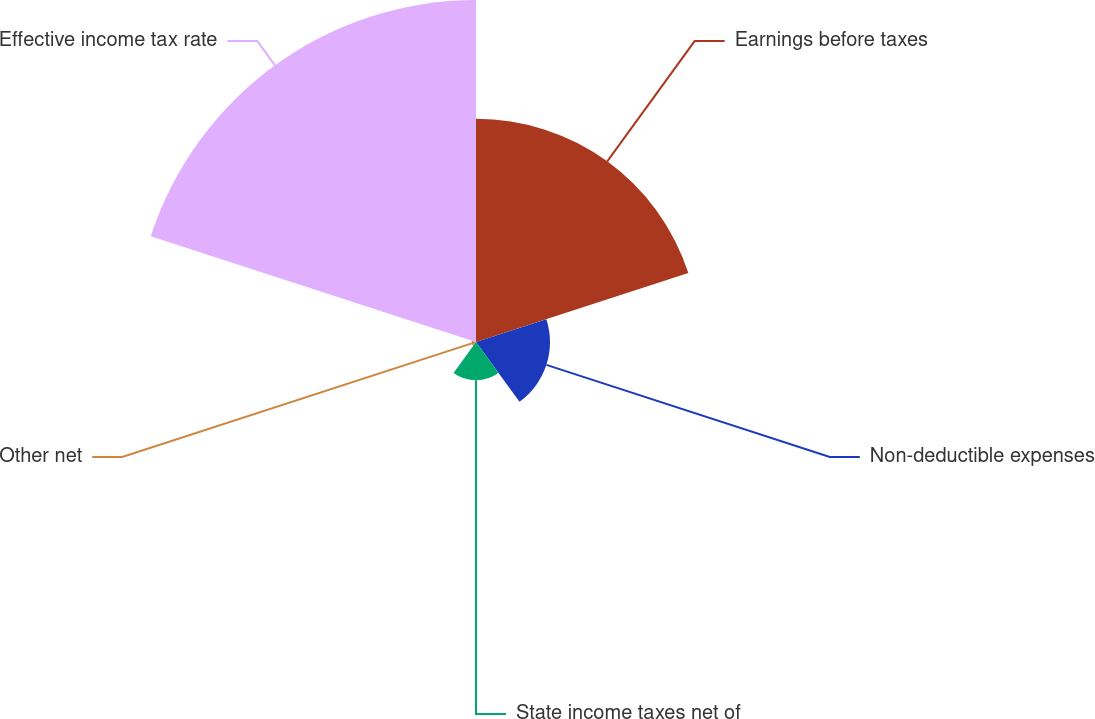<chart> <loc_0><loc_0><loc_500><loc_500><pie_chart><fcel>Earnings before taxes<fcel>Non-deductible expenses<fcel>State income taxes net of<fcel>Other net<fcel>Effective income tax rate<nl><fcel>32.74%<fcel>10.85%<fcel>5.6%<fcel>0.65%<fcel>50.15%<nl></chart> 